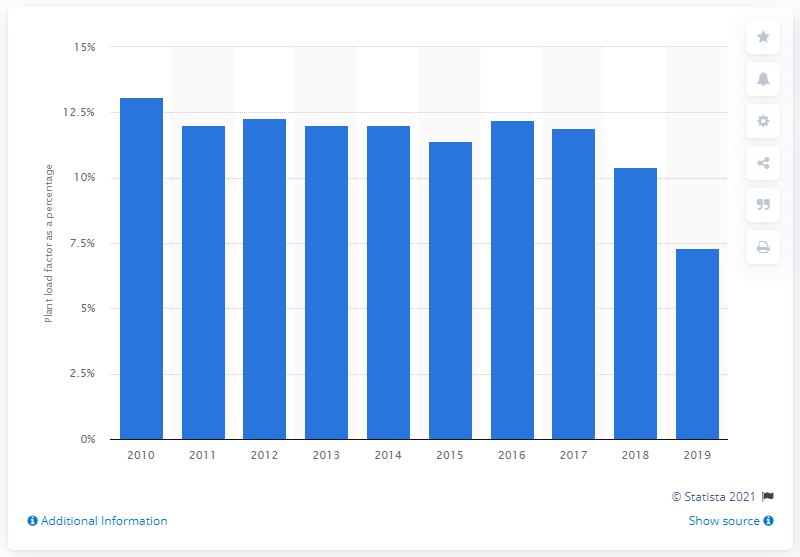Mention a couple of crucial points in this snapshot. The PLF of pumped storage hydroelectricity in 2019 was 7.3. Since 2010, the plant load factor of pumped storage hydroelectricity in the UK has experienced significant fluctuations. 